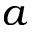<formula> <loc_0><loc_0><loc_500><loc_500>a</formula> 